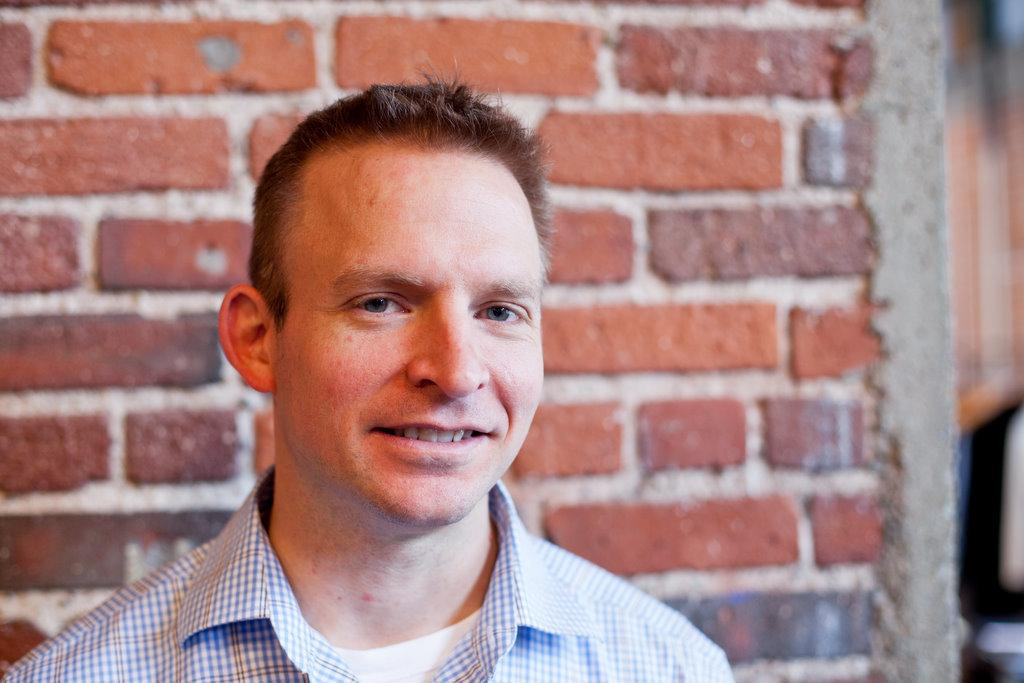What is the main subject in the foreground of the image? There is a person in the foreground of the image. What can be seen in the background of the image? There is a wall in the background of the image. Can you see a lake in the image? There is no lake present in the image; it only features a person in the foreground and a wall in the background. What is the person in the image reading? The image does not show the person reading anything, so it cannot be determined from the image. 